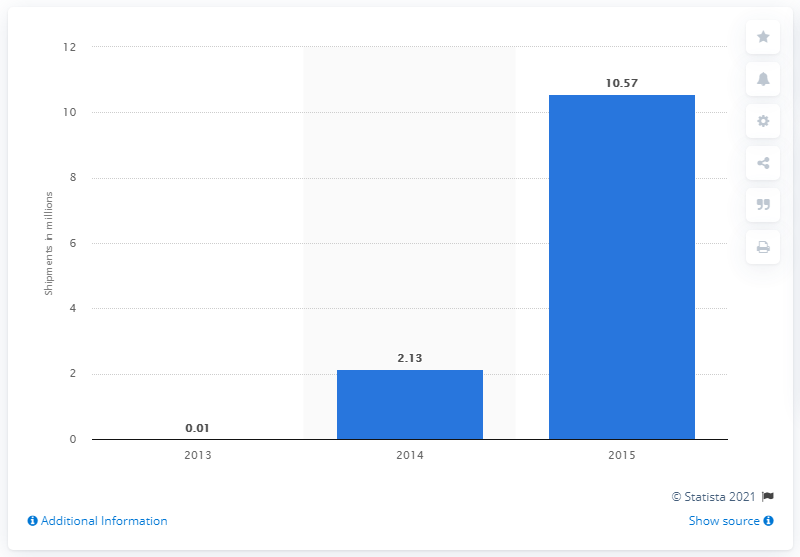Give some essential details in this illustration. It is forecasted that 10.57 units of smart glasses will be shipped in 2015. 